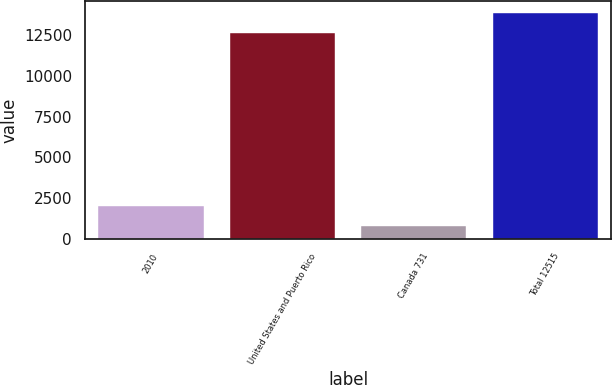<chart> <loc_0><loc_0><loc_500><loc_500><bar_chart><fcel>2010<fcel>United States and Puerto Rico<fcel>Canada 731<fcel>Total 12515<nl><fcel>2029.1<fcel>12621<fcel>767<fcel>13883.1<nl></chart> 